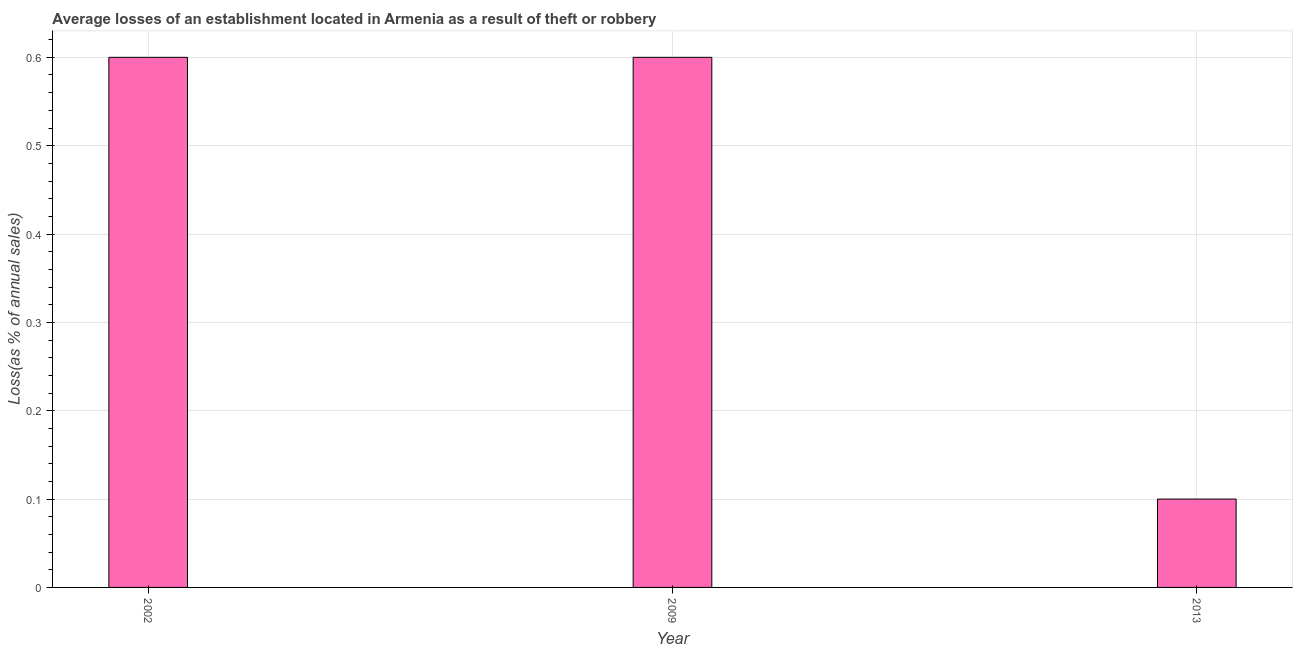Does the graph contain any zero values?
Provide a succinct answer. No. What is the title of the graph?
Your answer should be very brief. Average losses of an establishment located in Armenia as a result of theft or robbery. What is the label or title of the X-axis?
Ensure brevity in your answer.  Year. What is the label or title of the Y-axis?
Give a very brief answer. Loss(as % of annual sales). What is the losses due to theft in 2009?
Provide a succinct answer. 0.6. What is the sum of the losses due to theft?
Your answer should be very brief. 1.3. What is the difference between the losses due to theft in 2002 and 2013?
Your answer should be very brief. 0.5. What is the average losses due to theft per year?
Offer a very short reply. 0.43. In how many years, is the losses due to theft greater than 0.06 %?
Keep it short and to the point. 3. Do a majority of the years between 2009 and 2013 (inclusive) have losses due to theft greater than 0.56 %?
Your answer should be very brief. No. What is the ratio of the losses due to theft in 2002 to that in 2013?
Offer a terse response. 6. Is the difference between the losses due to theft in 2009 and 2013 greater than the difference between any two years?
Keep it short and to the point. Yes. What is the difference between the highest and the second highest losses due to theft?
Give a very brief answer. 0. Is the sum of the losses due to theft in 2002 and 2009 greater than the maximum losses due to theft across all years?
Offer a terse response. Yes. What is the difference between the highest and the lowest losses due to theft?
Offer a terse response. 0.5. How many bars are there?
Your response must be concise. 3. What is the Loss(as % of annual sales) of 2013?
Make the answer very short. 0.1. What is the difference between the Loss(as % of annual sales) in 2002 and 2009?
Your answer should be very brief. 0. What is the difference between the Loss(as % of annual sales) in 2002 and 2013?
Provide a succinct answer. 0.5. What is the difference between the Loss(as % of annual sales) in 2009 and 2013?
Offer a terse response. 0.5. What is the ratio of the Loss(as % of annual sales) in 2002 to that in 2009?
Give a very brief answer. 1. What is the ratio of the Loss(as % of annual sales) in 2002 to that in 2013?
Your answer should be very brief. 6. What is the ratio of the Loss(as % of annual sales) in 2009 to that in 2013?
Your answer should be very brief. 6. 